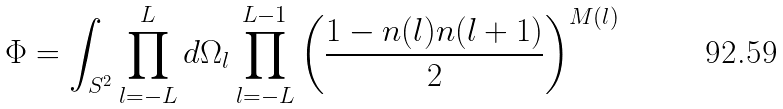Convert formula to latex. <formula><loc_0><loc_0><loc_500><loc_500>\Phi = \int _ { S ^ { 2 } } \prod _ { l = - L } ^ { L } d \Omega _ { l } \prod _ { l = - L } ^ { L - 1 } \left ( \frac { 1 - { n } ( l ) { n } ( l + 1 ) } { 2 } \right ) ^ { M ( l ) }</formula> 